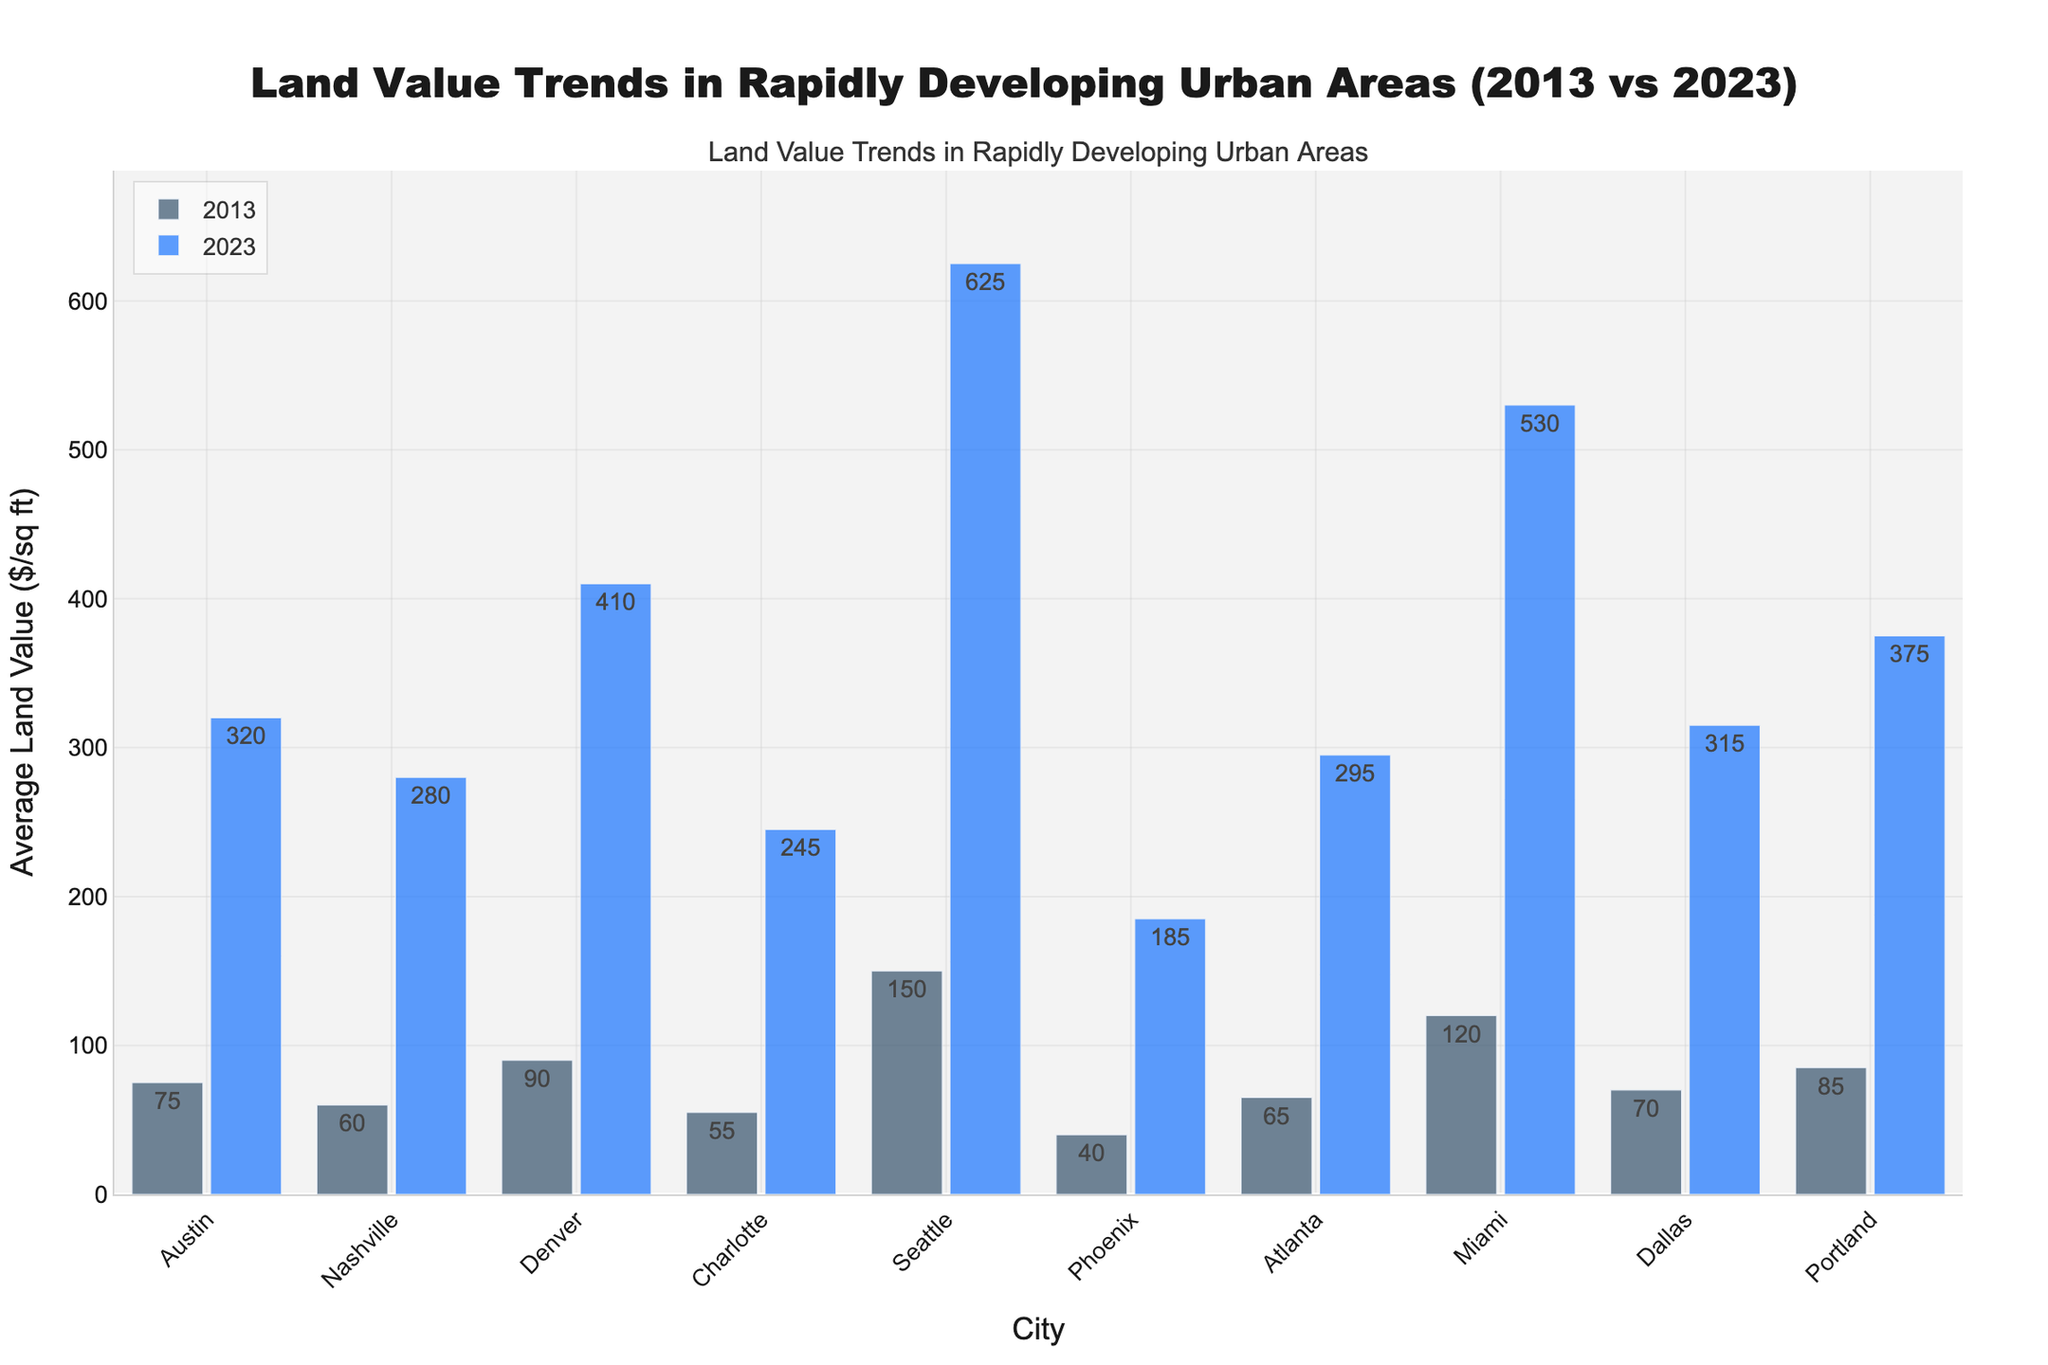Which city had the highest average land value in 2023? Look at the data points for each city in 2023. Identify the highest value among them. Seattle has the highest value at $625/sq ft.
Answer: Seattle Which city experienced the highest increase in average land value over the decade? Calculate the increase for each city from 2013 to 2023 by subtracting the value in 2013 from the value in 2023. The highest increase was in Seattle, from $150 to $625, an increase of $475/sq ft.
Answer: Seattle How much did the average land value increase in Denver from 2013 to 2023? Subtract the 2013 value ($90/sq ft) from the 2023 value ($410/sq ft) to get the increase. The increase is $410 - $90 = $320/sq ft.
Answer: $320 What is the average land value of Atlanta in 2023 and how does it compare to Miami's 2023 value? Refer to the 2023 value for both cities: Atlanta ($295/sq ft) and Miami ($530/sq ft). Compare the values $530/sq ft is greater than $295/sq ft.
Answer: $530 is greater than $295 Which city had the smallest increase in land value over the decade? Calculate the increase for each city and identify the smallest value. Phoenix had the smallest increase from $40 to $185, an increase of $145/sq ft.
Answer: Phoenix By how much did the average land value in Dallas change from 2013 to 2023? Subtract the 2013 value ($70/sq ft) from the 2023 value ($315/sq ft). The change is $315 - $70 = $245/sq ft.
Answer: $245 What is the difference in average land value between Portland and Atlanta in 2023? Subtract the 2023 value of Atlanta ($295/sq ft) from the 2023 value of Portland ($375/sq ft). The difference is $375 - $295 = $80/sq ft.
Answer: $80 Compare Charlotte's and Phoenix's land values in 2013 and 2023. Which city saw a greater proportional increase? Compute the proportional increase for each city by dividing the increase by the 2013 value: Charlotte's increase ($245 - $55 = $190), proportional increase 190/55 ≈ 3.45; Phoenix's increase ($185 - $40 = $145), proportional increase 145/40 ≈ 3.625. Phoenix saw a greater proportional increase.
Answer: Phoenix What are the average land values for Austin in 2013 and 2023 and their difference? Austin's values are $75/sq ft in 2013 and $320/sq ft in 2023. The difference is $320 - $75 = $245/sq ft.
Answer: $245 Visual comparison: Which city's bar for average land value in 2013 is nearly half the height of its 2023 bar? Look for bars where the 2013 bar is nearly half the height of the 2023 bar. In Atlanta, the 2013 value ($65/sq ft) is almost half of the 2023 value ($295/sq ft).
Answer: Atlanta 